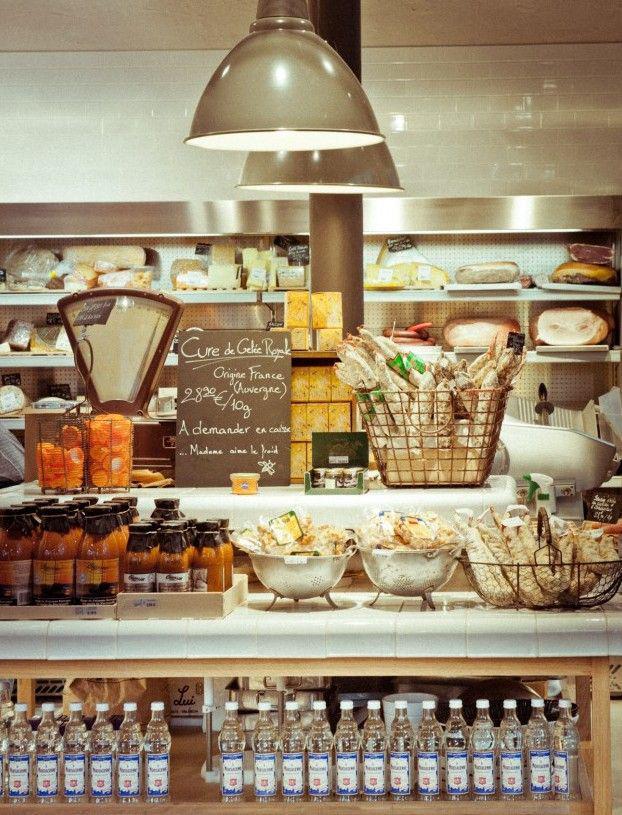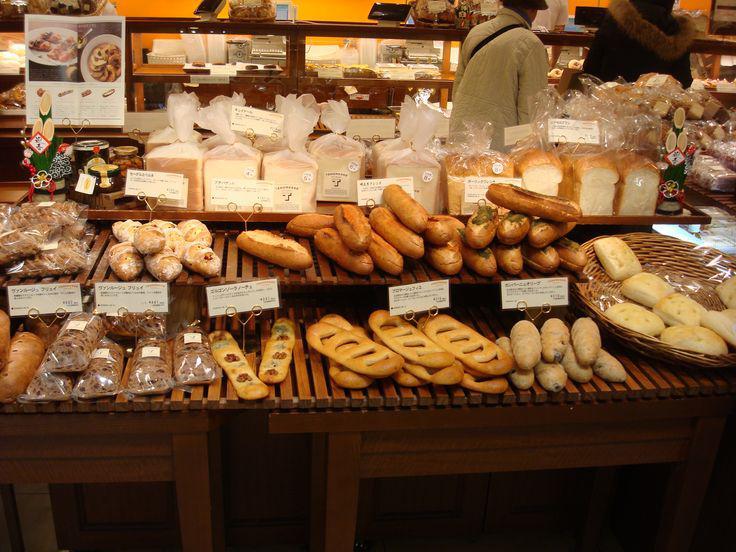The first image is the image on the left, the second image is the image on the right. Evaluate the accuracy of this statement regarding the images: "There are many loaves of bread in the image on the right". Is it true? Answer yes or no. Yes. The first image is the image on the left, the second image is the image on the right. For the images shown, is this caption "There is at least one purple label in one of the images." true? Answer yes or no. No. The first image is the image on the left, the second image is the image on the right. Assess this claim about the two images: "At least one image includes lights above the bakery displays.". Correct or not? Answer yes or no. Yes. The first image is the image on the left, the second image is the image on the right. Given the left and right images, does the statement "At least one person is near bread products in one image." hold true? Answer yes or no. Yes. 